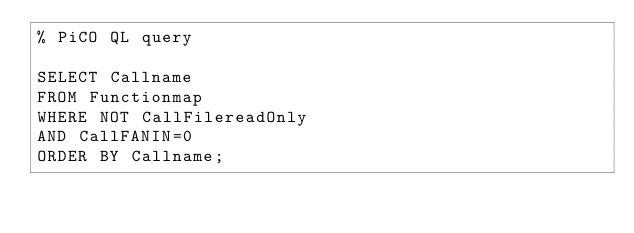<code> <loc_0><loc_0><loc_500><loc_500><_SQL_>% PiCO QL query

SELECT Callname 
FROM Functionmap
WHERE NOT CallFilereadOnly 
AND CallFANIN=0
ORDER BY Callname;
</code> 